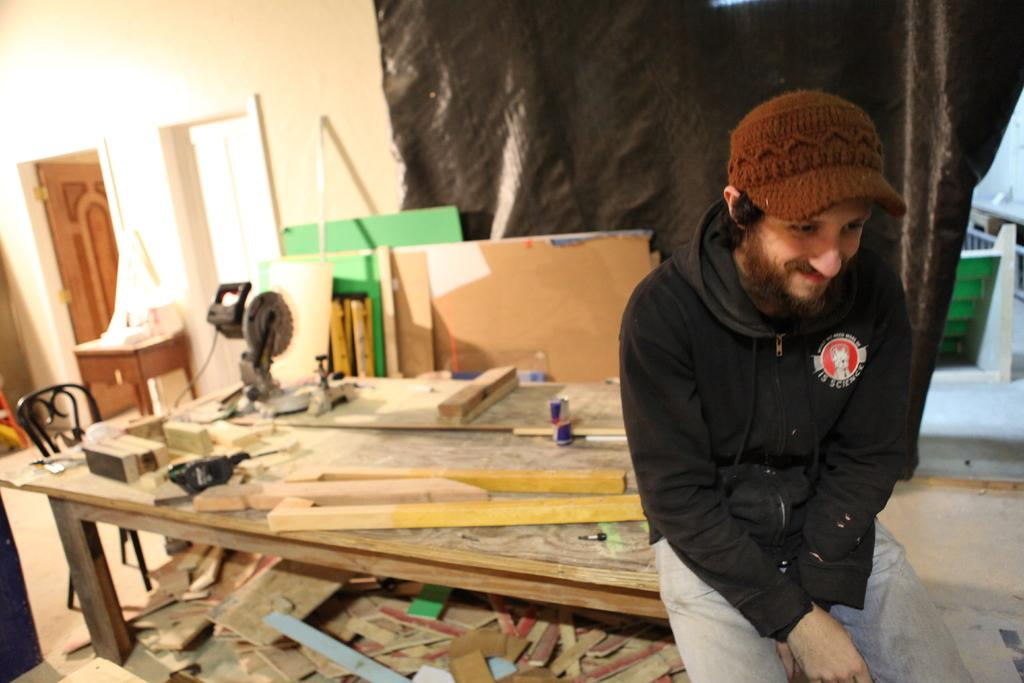What is the person in the image doing? The person is sitting on the table in the image. What objects are on the table with the person? There are carpentry tools on the table in the image. Is there any furniture near the table? Yes, there is a chair near the table in the image. How many horses can be seen in the image? There are no horses present in the image. What day of the week is depicted in the image? The image does not show a specific day of the week. 